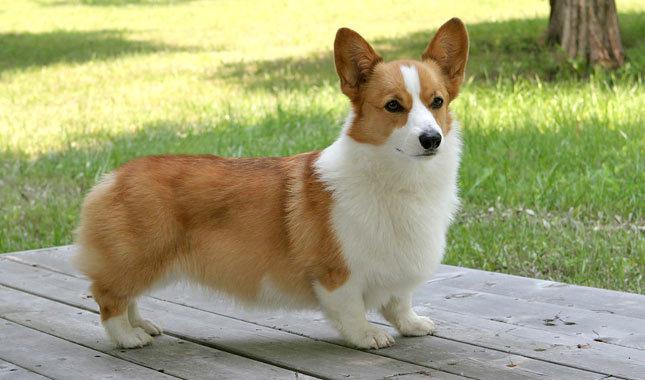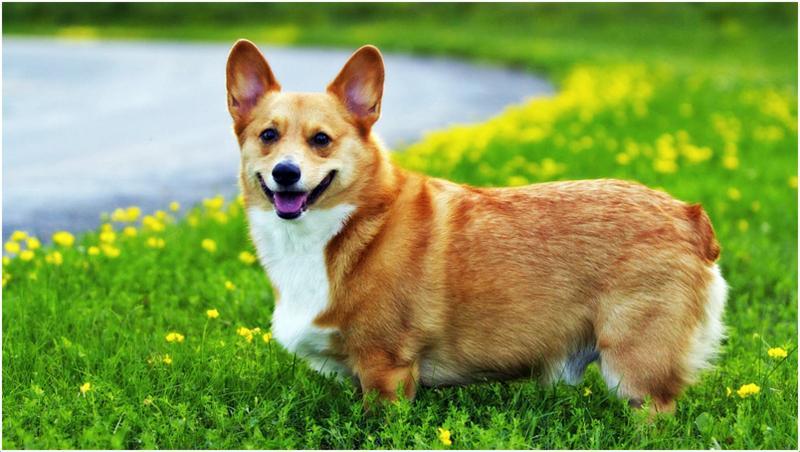The first image is the image on the left, the second image is the image on the right. Assess this claim about the two images: "Both images show short-legged dogs standing on grass.". Correct or not? Answer yes or no. No. 